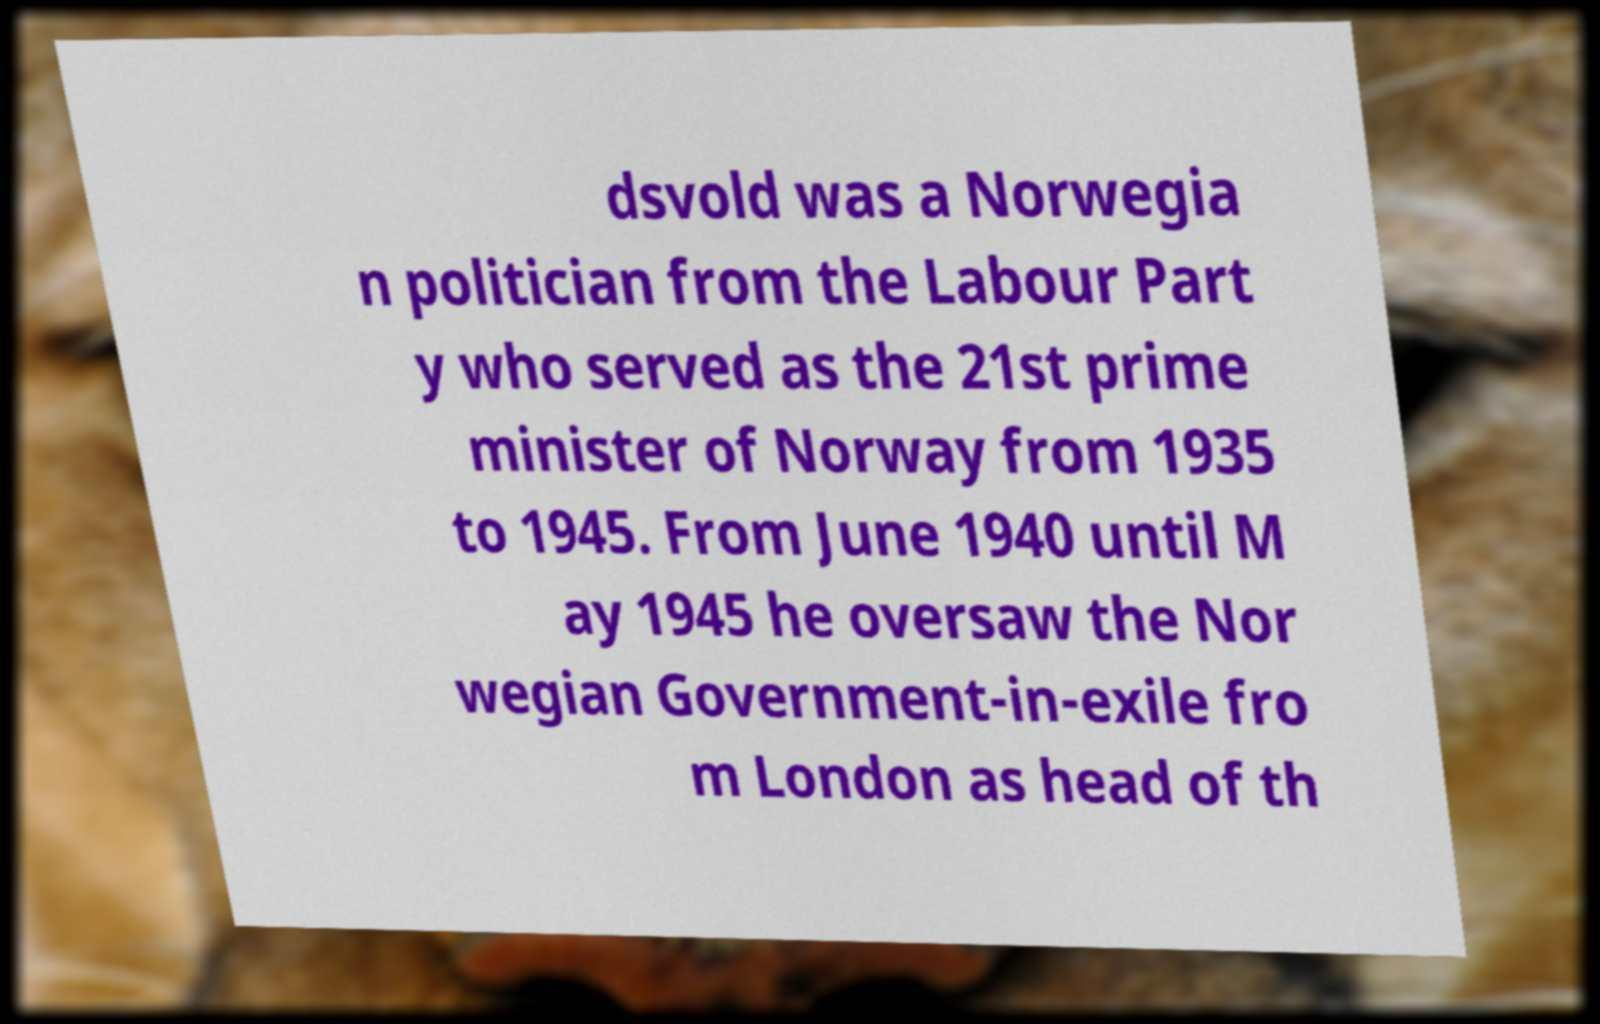I need the written content from this picture converted into text. Can you do that? dsvold was a Norwegia n politician from the Labour Part y who served as the 21st prime minister of Norway from 1935 to 1945. From June 1940 until M ay 1945 he oversaw the Nor wegian Government-in-exile fro m London as head of th 